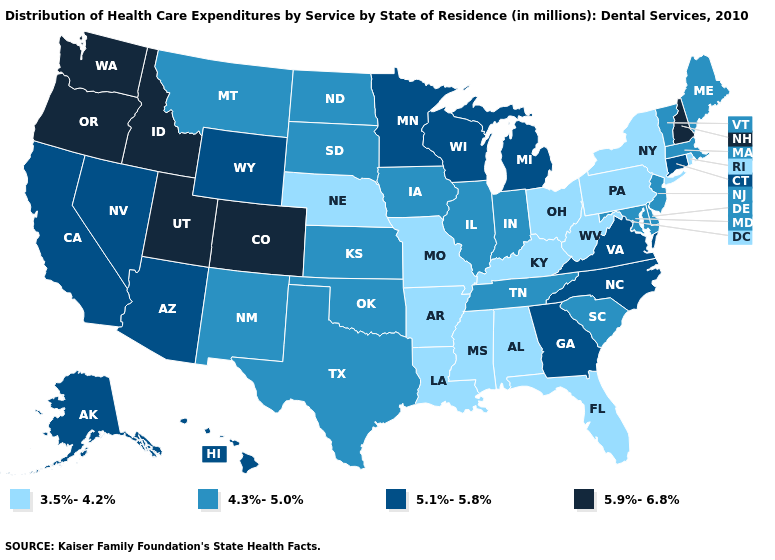Name the states that have a value in the range 5.1%-5.8%?
Be succinct. Alaska, Arizona, California, Connecticut, Georgia, Hawaii, Michigan, Minnesota, Nevada, North Carolina, Virginia, Wisconsin, Wyoming. Name the states that have a value in the range 5.9%-6.8%?
Concise answer only. Colorado, Idaho, New Hampshire, Oregon, Utah, Washington. Name the states that have a value in the range 5.9%-6.8%?
Concise answer only. Colorado, Idaho, New Hampshire, Oregon, Utah, Washington. What is the value of Indiana?
Answer briefly. 4.3%-5.0%. Does Alabama have the highest value in the South?
Quick response, please. No. What is the lowest value in the USA?
Give a very brief answer. 3.5%-4.2%. Which states have the lowest value in the USA?
Be succinct. Alabama, Arkansas, Florida, Kentucky, Louisiana, Mississippi, Missouri, Nebraska, New York, Ohio, Pennsylvania, Rhode Island, West Virginia. Does Oklahoma have a higher value than Virginia?
Keep it brief. No. How many symbols are there in the legend?
Concise answer only. 4. Name the states that have a value in the range 5.9%-6.8%?
Quick response, please. Colorado, Idaho, New Hampshire, Oregon, Utah, Washington. Does New York have the lowest value in the Northeast?
Be succinct. Yes. Name the states that have a value in the range 5.1%-5.8%?
Answer briefly. Alaska, Arizona, California, Connecticut, Georgia, Hawaii, Michigan, Minnesota, Nevada, North Carolina, Virginia, Wisconsin, Wyoming. Name the states that have a value in the range 5.9%-6.8%?
Concise answer only. Colorado, Idaho, New Hampshire, Oregon, Utah, Washington. Does the map have missing data?
Concise answer only. No. What is the highest value in the Northeast ?
Keep it brief. 5.9%-6.8%. 